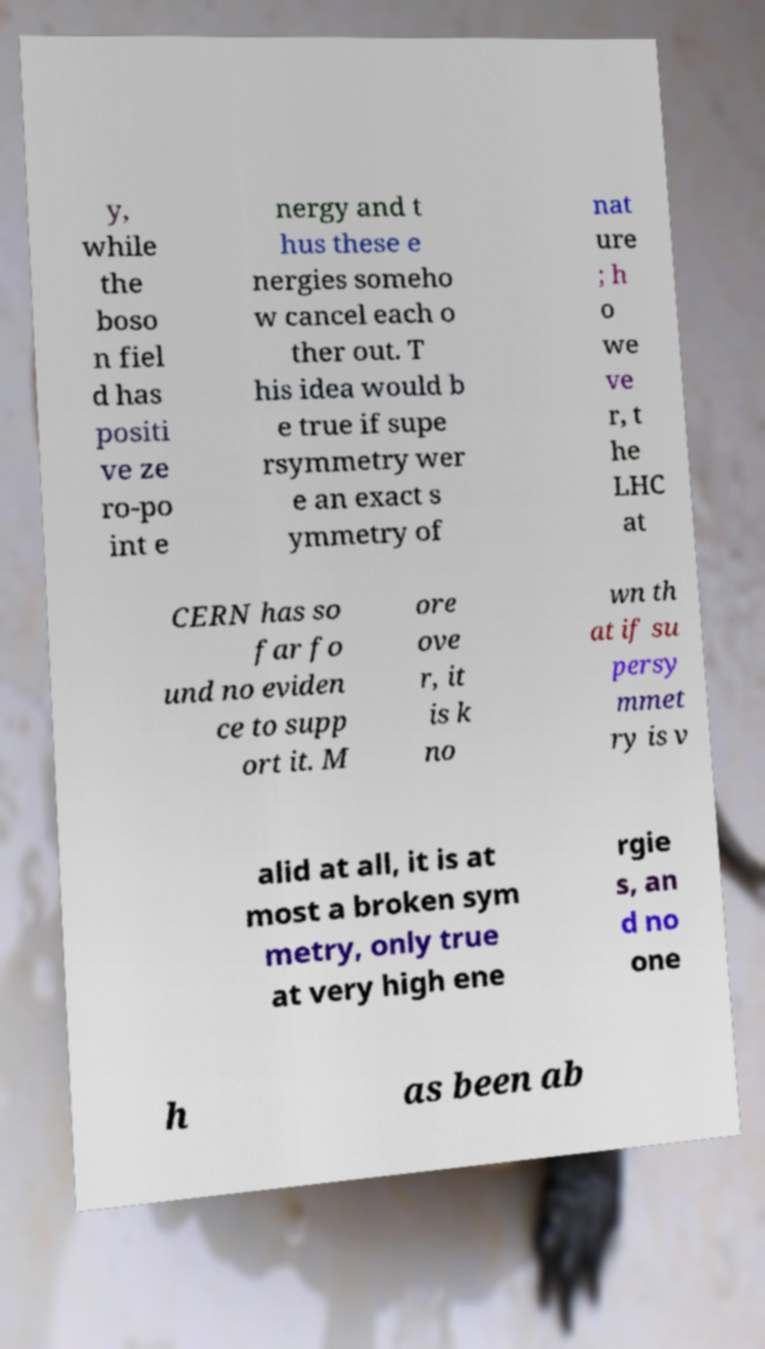Could you assist in decoding the text presented in this image and type it out clearly? y, while the boso n fiel d has positi ve ze ro-po int e nergy and t hus these e nergies someho w cancel each o ther out. T his idea would b e true if supe rsymmetry wer e an exact s ymmetry of nat ure ; h o we ve r, t he LHC at CERN has so far fo und no eviden ce to supp ort it. M ore ove r, it is k no wn th at if su persy mmet ry is v alid at all, it is at most a broken sym metry, only true at very high ene rgie s, an d no one h as been ab 